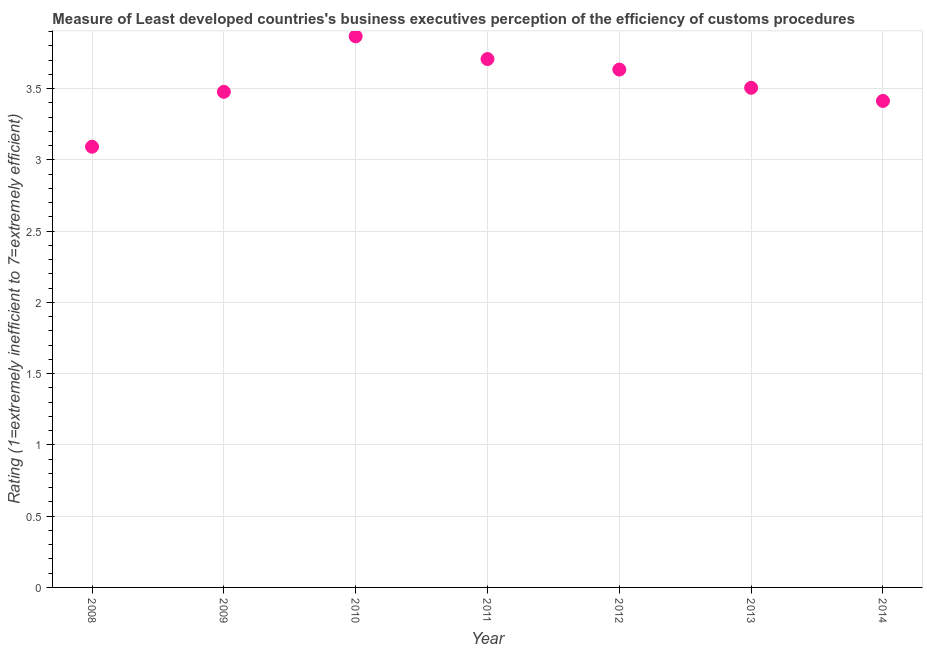What is the rating measuring burden of customs procedure in 2009?
Your answer should be compact. 3.48. Across all years, what is the maximum rating measuring burden of customs procedure?
Your answer should be very brief. 3.87. Across all years, what is the minimum rating measuring burden of customs procedure?
Offer a terse response. 3.09. In which year was the rating measuring burden of customs procedure maximum?
Provide a succinct answer. 2010. In which year was the rating measuring burden of customs procedure minimum?
Give a very brief answer. 2008. What is the sum of the rating measuring burden of customs procedure?
Make the answer very short. 24.7. What is the difference between the rating measuring burden of customs procedure in 2008 and 2013?
Offer a very short reply. -0.41. What is the average rating measuring burden of customs procedure per year?
Your answer should be compact. 3.53. What is the median rating measuring burden of customs procedure?
Make the answer very short. 3.51. In how many years, is the rating measuring burden of customs procedure greater than 1.5 ?
Provide a short and direct response. 7. Do a majority of the years between 2012 and 2008 (inclusive) have rating measuring burden of customs procedure greater than 0.2 ?
Your response must be concise. Yes. What is the ratio of the rating measuring burden of customs procedure in 2013 to that in 2014?
Your answer should be very brief. 1.03. Is the difference between the rating measuring burden of customs procedure in 2008 and 2011 greater than the difference between any two years?
Your response must be concise. No. What is the difference between the highest and the second highest rating measuring burden of customs procedure?
Ensure brevity in your answer.  0.16. What is the difference between the highest and the lowest rating measuring burden of customs procedure?
Offer a terse response. 0.77. In how many years, is the rating measuring burden of customs procedure greater than the average rating measuring burden of customs procedure taken over all years?
Give a very brief answer. 3. Does the rating measuring burden of customs procedure monotonically increase over the years?
Ensure brevity in your answer.  No. What is the difference between two consecutive major ticks on the Y-axis?
Your answer should be very brief. 0.5. Does the graph contain grids?
Provide a short and direct response. Yes. What is the title of the graph?
Your answer should be compact. Measure of Least developed countries's business executives perception of the efficiency of customs procedures. What is the label or title of the Y-axis?
Your response must be concise. Rating (1=extremely inefficient to 7=extremely efficient). What is the Rating (1=extremely inefficient to 7=extremely efficient) in 2008?
Your answer should be compact. 3.09. What is the Rating (1=extremely inefficient to 7=extremely efficient) in 2009?
Ensure brevity in your answer.  3.48. What is the Rating (1=extremely inefficient to 7=extremely efficient) in 2010?
Your answer should be compact. 3.87. What is the Rating (1=extremely inefficient to 7=extremely efficient) in 2011?
Provide a short and direct response. 3.71. What is the Rating (1=extremely inefficient to 7=extremely efficient) in 2012?
Make the answer very short. 3.63. What is the Rating (1=extremely inefficient to 7=extremely efficient) in 2013?
Ensure brevity in your answer.  3.51. What is the Rating (1=extremely inefficient to 7=extremely efficient) in 2014?
Keep it short and to the point. 3.41. What is the difference between the Rating (1=extremely inefficient to 7=extremely efficient) in 2008 and 2009?
Provide a succinct answer. -0.39. What is the difference between the Rating (1=extremely inefficient to 7=extremely efficient) in 2008 and 2010?
Offer a terse response. -0.77. What is the difference between the Rating (1=extremely inefficient to 7=extremely efficient) in 2008 and 2011?
Offer a very short reply. -0.62. What is the difference between the Rating (1=extremely inefficient to 7=extremely efficient) in 2008 and 2012?
Provide a short and direct response. -0.54. What is the difference between the Rating (1=extremely inefficient to 7=extremely efficient) in 2008 and 2013?
Your response must be concise. -0.41. What is the difference between the Rating (1=extremely inefficient to 7=extremely efficient) in 2008 and 2014?
Offer a terse response. -0.32. What is the difference between the Rating (1=extremely inefficient to 7=extremely efficient) in 2009 and 2010?
Provide a succinct answer. -0.39. What is the difference between the Rating (1=extremely inefficient to 7=extremely efficient) in 2009 and 2011?
Offer a very short reply. -0.23. What is the difference between the Rating (1=extremely inefficient to 7=extremely efficient) in 2009 and 2012?
Your answer should be very brief. -0.16. What is the difference between the Rating (1=extremely inefficient to 7=extremely efficient) in 2009 and 2013?
Keep it short and to the point. -0.03. What is the difference between the Rating (1=extremely inefficient to 7=extremely efficient) in 2009 and 2014?
Provide a short and direct response. 0.06. What is the difference between the Rating (1=extremely inefficient to 7=extremely efficient) in 2010 and 2011?
Offer a terse response. 0.16. What is the difference between the Rating (1=extremely inefficient to 7=extremely efficient) in 2010 and 2012?
Keep it short and to the point. 0.23. What is the difference between the Rating (1=extremely inefficient to 7=extremely efficient) in 2010 and 2013?
Your answer should be compact. 0.36. What is the difference between the Rating (1=extremely inefficient to 7=extremely efficient) in 2010 and 2014?
Ensure brevity in your answer.  0.45. What is the difference between the Rating (1=extremely inefficient to 7=extremely efficient) in 2011 and 2012?
Offer a very short reply. 0.07. What is the difference between the Rating (1=extremely inefficient to 7=extremely efficient) in 2011 and 2013?
Your response must be concise. 0.2. What is the difference between the Rating (1=extremely inefficient to 7=extremely efficient) in 2011 and 2014?
Give a very brief answer. 0.29. What is the difference between the Rating (1=extremely inefficient to 7=extremely efficient) in 2012 and 2013?
Keep it short and to the point. 0.13. What is the difference between the Rating (1=extremely inefficient to 7=extremely efficient) in 2012 and 2014?
Your answer should be very brief. 0.22. What is the difference between the Rating (1=extremely inefficient to 7=extremely efficient) in 2013 and 2014?
Your answer should be compact. 0.09. What is the ratio of the Rating (1=extremely inefficient to 7=extremely efficient) in 2008 to that in 2009?
Provide a succinct answer. 0.89. What is the ratio of the Rating (1=extremely inefficient to 7=extremely efficient) in 2008 to that in 2010?
Offer a very short reply. 0.8. What is the ratio of the Rating (1=extremely inefficient to 7=extremely efficient) in 2008 to that in 2011?
Provide a succinct answer. 0.83. What is the ratio of the Rating (1=extremely inefficient to 7=extremely efficient) in 2008 to that in 2012?
Offer a very short reply. 0.85. What is the ratio of the Rating (1=extremely inefficient to 7=extremely efficient) in 2008 to that in 2013?
Provide a succinct answer. 0.88. What is the ratio of the Rating (1=extremely inefficient to 7=extremely efficient) in 2008 to that in 2014?
Provide a succinct answer. 0.91. What is the ratio of the Rating (1=extremely inefficient to 7=extremely efficient) in 2009 to that in 2010?
Ensure brevity in your answer.  0.9. What is the ratio of the Rating (1=extremely inefficient to 7=extremely efficient) in 2009 to that in 2011?
Ensure brevity in your answer.  0.94. What is the ratio of the Rating (1=extremely inefficient to 7=extremely efficient) in 2009 to that in 2013?
Provide a short and direct response. 0.99. What is the ratio of the Rating (1=extremely inefficient to 7=extremely efficient) in 2009 to that in 2014?
Your response must be concise. 1.02. What is the ratio of the Rating (1=extremely inefficient to 7=extremely efficient) in 2010 to that in 2011?
Provide a short and direct response. 1.04. What is the ratio of the Rating (1=extremely inefficient to 7=extremely efficient) in 2010 to that in 2012?
Your answer should be very brief. 1.06. What is the ratio of the Rating (1=extremely inefficient to 7=extremely efficient) in 2010 to that in 2013?
Offer a terse response. 1.1. What is the ratio of the Rating (1=extremely inefficient to 7=extremely efficient) in 2010 to that in 2014?
Provide a short and direct response. 1.13. What is the ratio of the Rating (1=extremely inefficient to 7=extremely efficient) in 2011 to that in 2013?
Provide a short and direct response. 1.06. What is the ratio of the Rating (1=extremely inefficient to 7=extremely efficient) in 2011 to that in 2014?
Your response must be concise. 1.09. What is the ratio of the Rating (1=extremely inefficient to 7=extremely efficient) in 2012 to that in 2013?
Offer a very short reply. 1.04. What is the ratio of the Rating (1=extremely inefficient to 7=extremely efficient) in 2012 to that in 2014?
Provide a short and direct response. 1.06. 